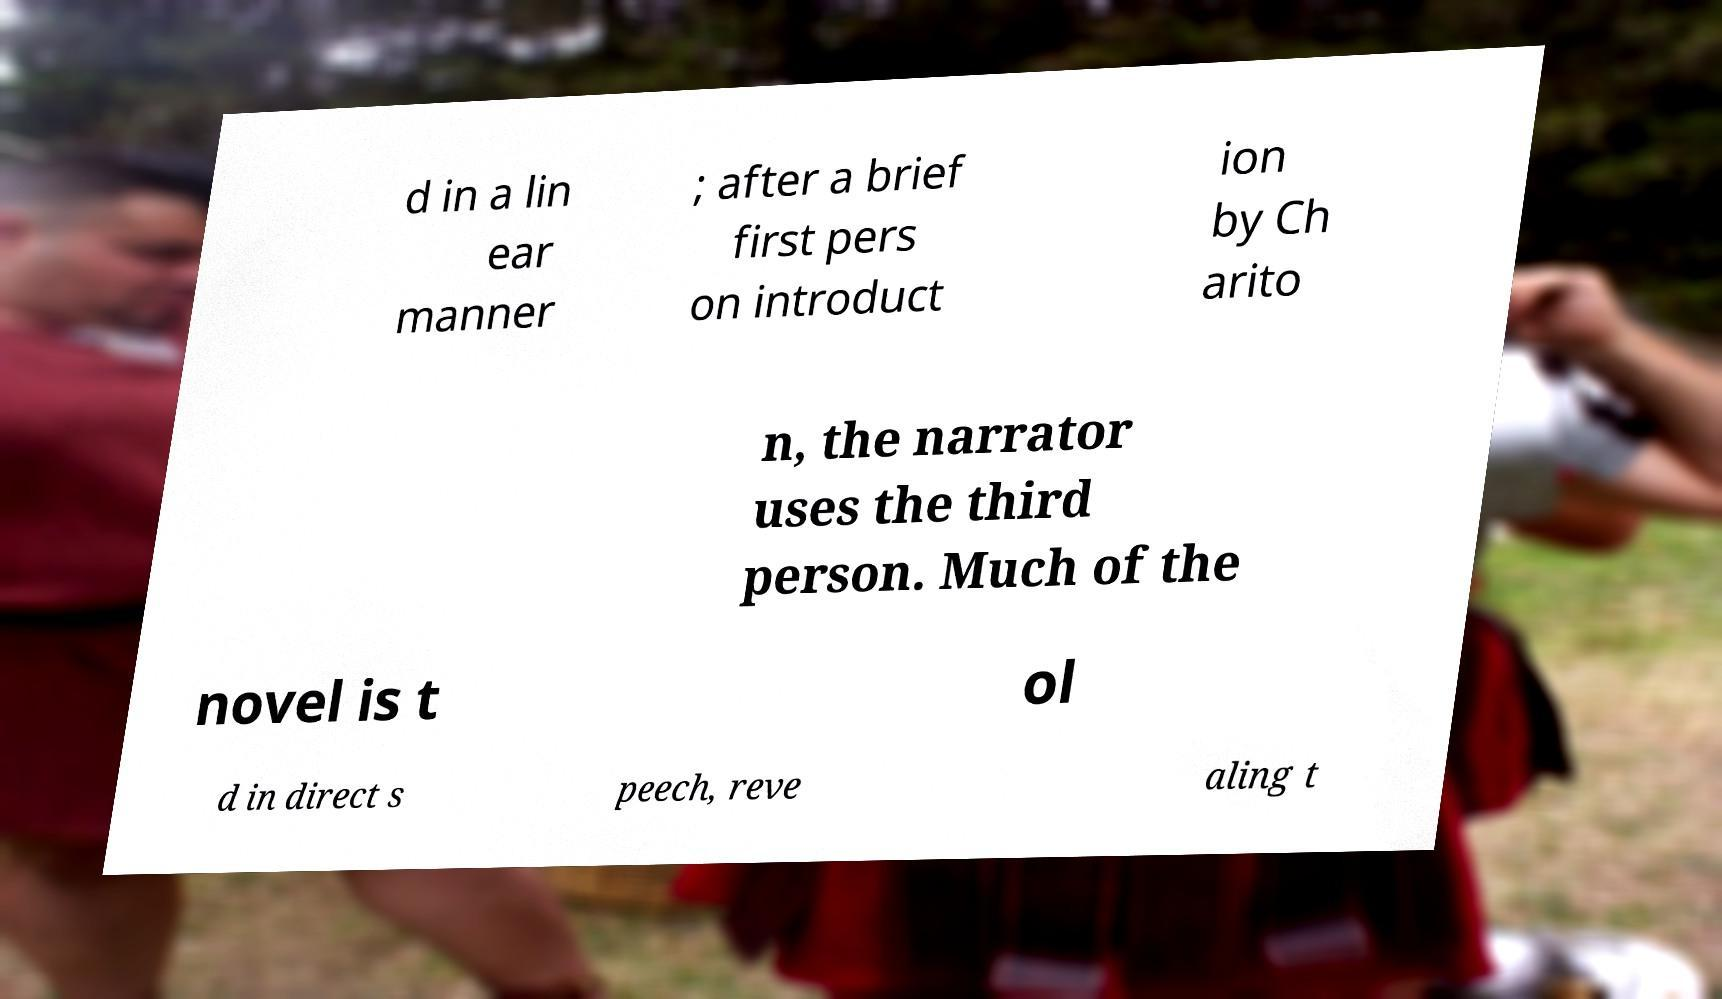I need the written content from this picture converted into text. Can you do that? d in a lin ear manner ; after a brief first pers on introduct ion by Ch arito n, the narrator uses the third person. Much of the novel is t ol d in direct s peech, reve aling t 